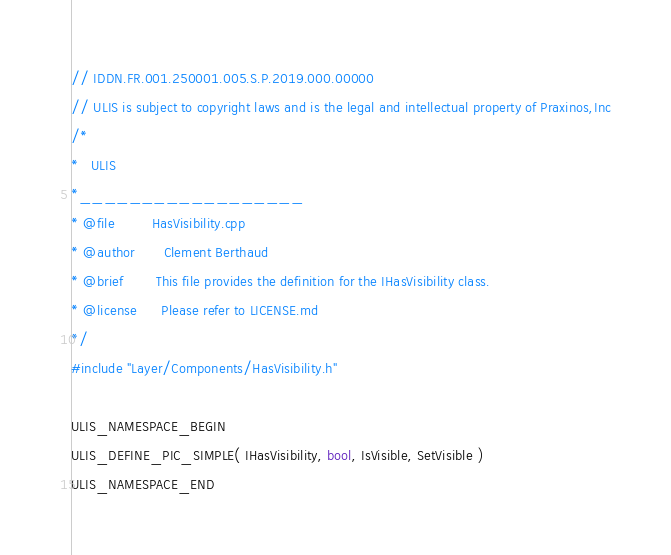Convert code to text. <code><loc_0><loc_0><loc_500><loc_500><_C++_>// IDDN.FR.001.250001.005.S.P.2019.000.00000
// ULIS is subject to copyright laws and is the legal and intellectual property of Praxinos,Inc
/*
*   ULIS
*__________________
* @file         HasVisibility.cpp
* @author       Clement Berthaud
* @brief        This file provides the definition for the IHasVisibility class.
* @license      Please refer to LICENSE.md
*/
#include "Layer/Components/HasVisibility.h"

ULIS_NAMESPACE_BEGIN
ULIS_DEFINE_PIC_SIMPLE( IHasVisibility, bool, IsVisible, SetVisible )
ULIS_NAMESPACE_END

</code> 